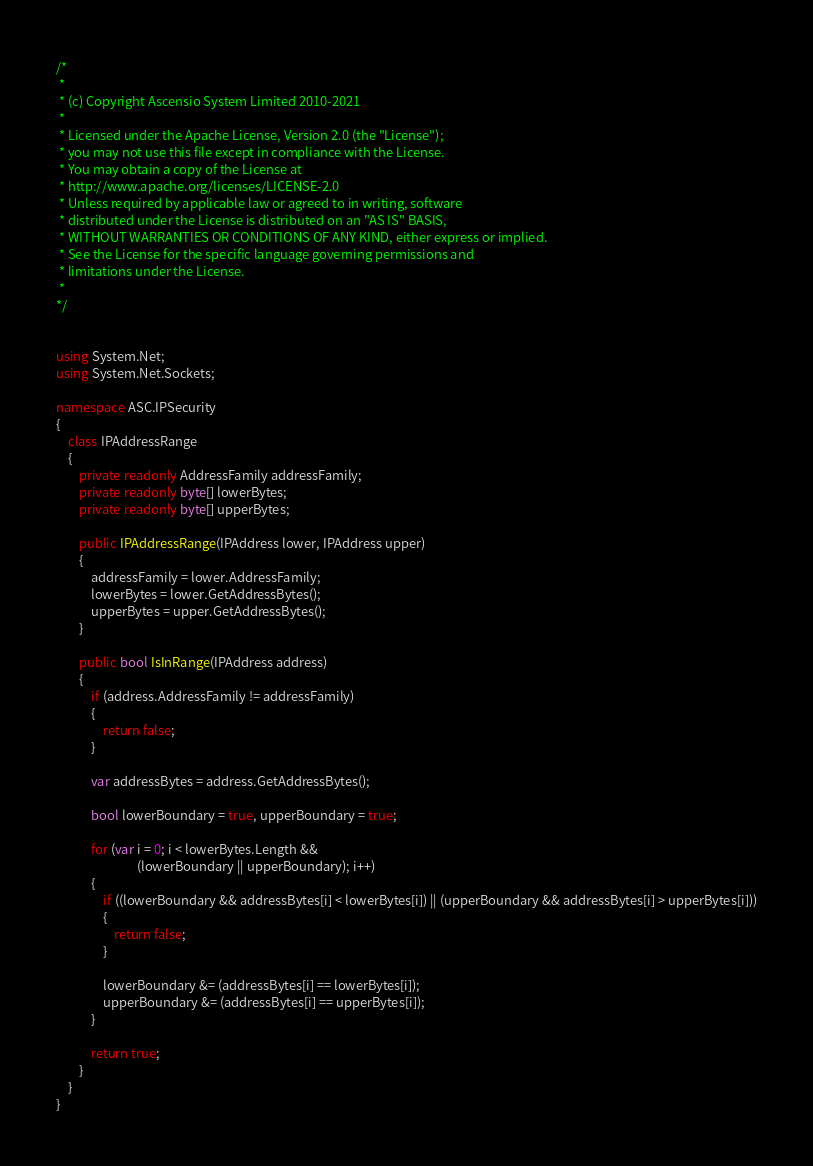Convert code to text. <code><loc_0><loc_0><loc_500><loc_500><_C#_>/*
 *
 * (c) Copyright Ascensio System Limited 2010-2021
 * 
 * Licensed under the Apache License, Version 2.0 (the "License");
 * you may not use this file except in compliance with the License.
 * You may obtain a copy of the License at
 * http://www.apache.org/licenses/LICENSE-2.0
 * Unless required by applicable law or agreed to in writing, software
 * distributed under the License is distributed on an "AS IS" BASIS,
 * WITHOUT WARRANTIES OR CONDITIONS OF ANY KIND, either express or implied.
 * See the License for the specific language governing permissions and
 * limitations under the License.
 *
*/


using System.Net;
using System.Net.Sockets;

namespace ASC.IPSecurity
{
    class IPAddressRange
    {
        private readonly AddressFamily addressFamily;
        private readonly byte[] lowerBytes;
        private readonly byte[] upperBytes;

        public IPAddressRange(IPAddress lower, IPAddress upper)
        {
            addressFamily = lower.AddressFamily;
            lowerBytes = lower.GetAddressBytes();
            upperBytes = upper.GetAddressBytes();
        }

        public bool IsInRange(IPAddress address)
        {
            if (address.AddressFamily != addressFamily)
            {
                return false;
            }

            var addressBytes = address.GetAddressBytes();

            bool lowerBoundary = true, upperBoundary = true;

            for (var i = 0; i < lowerBytes.Length &&
                            (lowerBoundary || upperBoundary); i++)
            {
                if ((lowerBoundary && addressBytes[i] < lowerBytes[i]) || (upperBoundary && addressBytes[i] > upperBytes[i]))
                {
                    return false;
                }

                lowerBoundary &= (addressBytes[i] == lowerBytes[i]);
                upperBoundary &= (addressBytes[i] == upperBytes[i]);
            }

            return true;
        }
    }
}</code> 